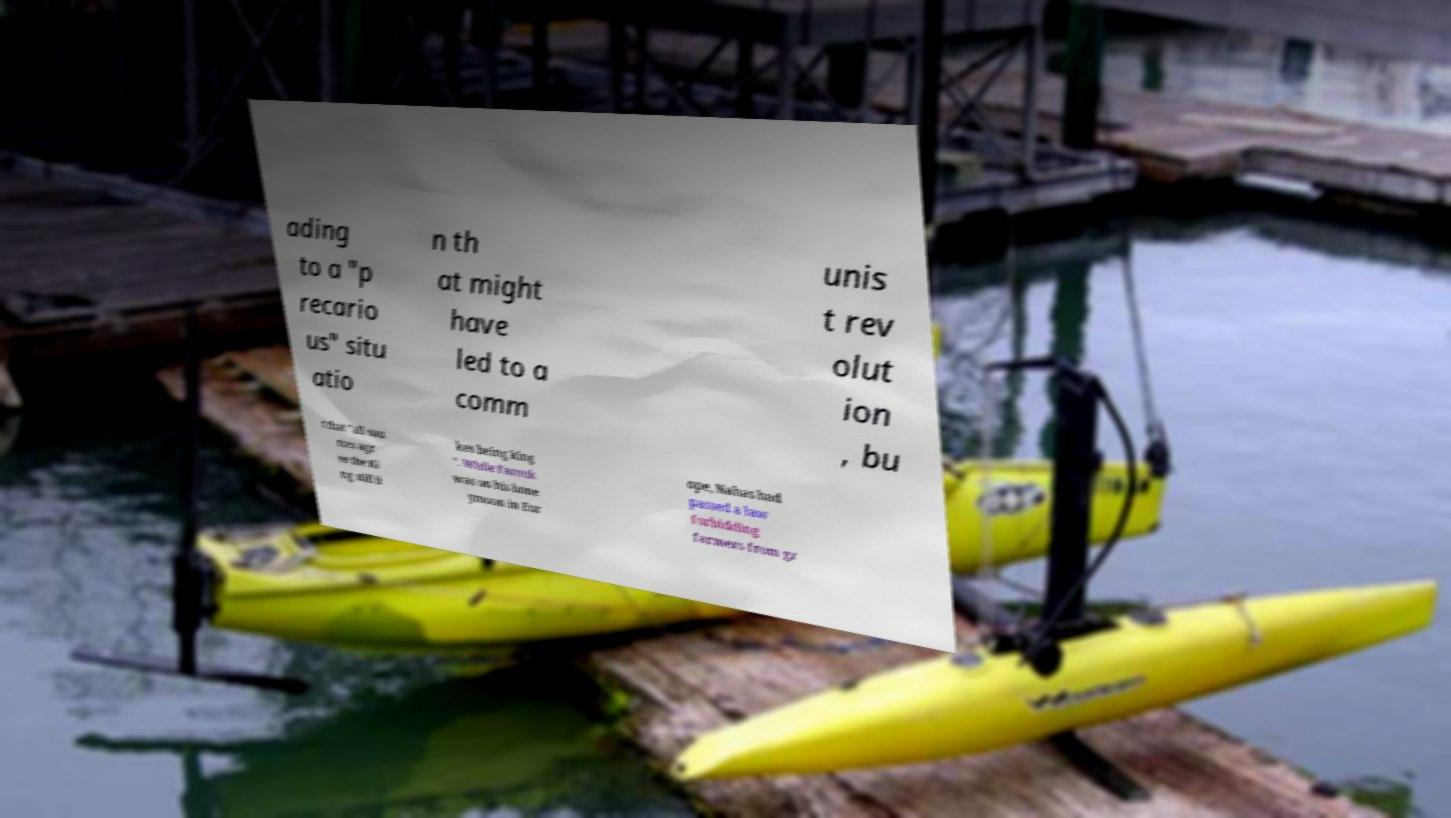Please identify and transcribe the text found in this image. ading to a "p recario us" situ atio n th at might have led to a comm unis t rev olut ion , bu t that "all sou rces agr ee the Ki ng still li kes being king ". While Farouk was on his hone ymoon in Eur ope, Nahas had passed a law forbidding farmers from gr 